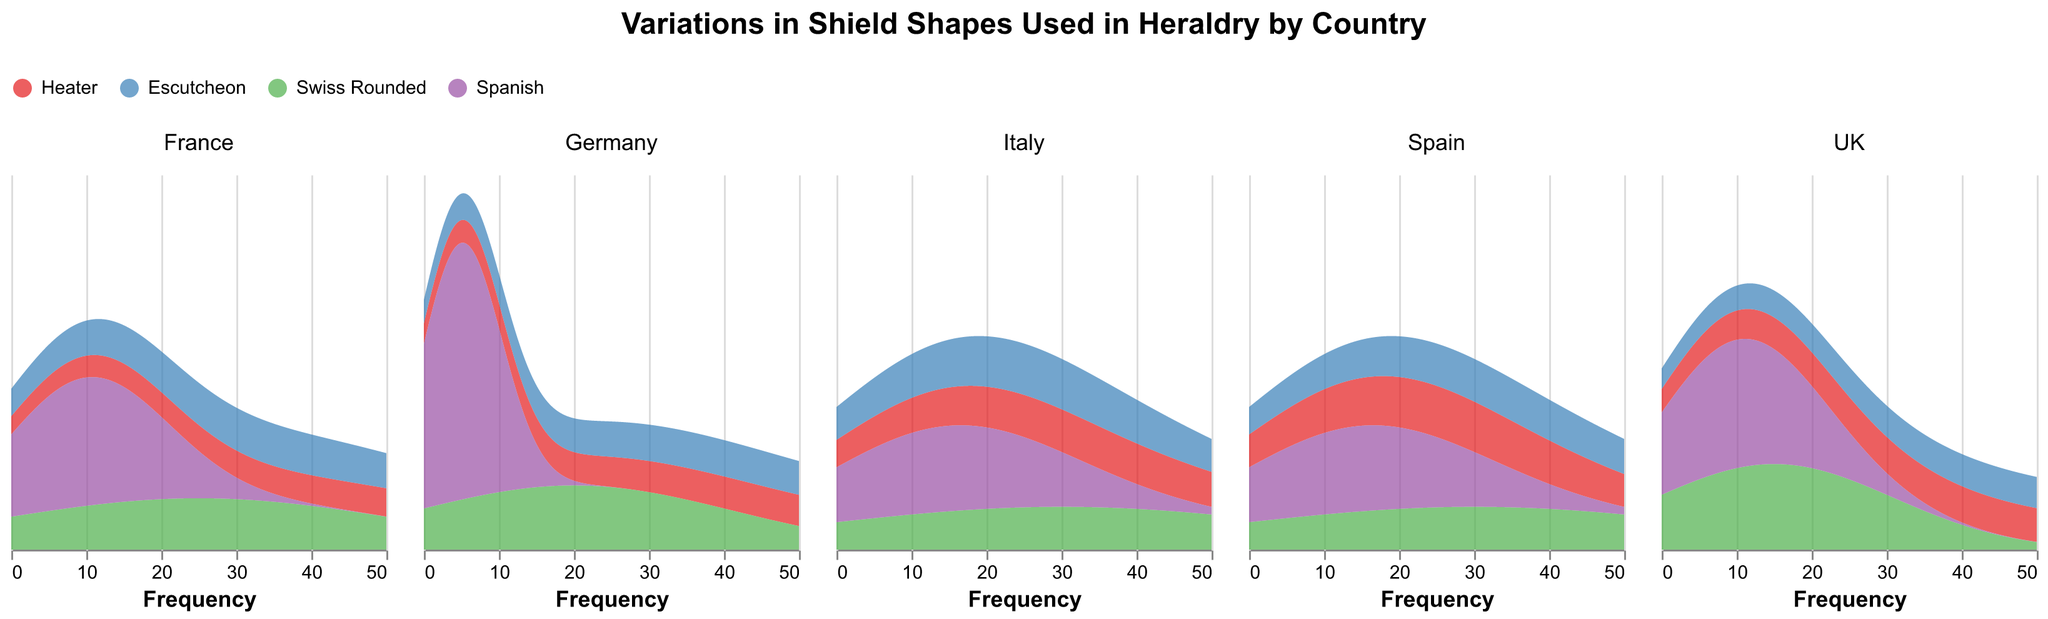What is the most common shield shape in France? To determine this, you can look at the highest peak in the density plot for France. Heater has the highest frequency with 45.
Answer: Heater Which country has the highest frequency for the Escutcheon shield shape? You need to compare the peaks for the Escutcheon shape in all countries. The UK shows the highest peak at a frequency of 40.
Answer: UK How many shield shapes are displayed in each subplot? Each subplot represents four different shield shapes as indicated by the color legend: Heater, Escutcheon, Swiss Rounded, and Spanish.
Answer: 4 Comparing Germany and Italy, which country uses the Swiss Rounded shape more frequently? Look at the heights of the density plots for Swiss Rounded in Germany and Italy. Italy has a higher frequency of 30 compared to Germany's 20.
Answer: Italy What is the combined frequency of the Spanish shield shape in Spain and Italy? Sum the frequencies of the Spanish shield shape in Spain (15) and Italy (15): 15 + 15 = 30.
Answer: 30 Which shield shape is the least common in Germany? By reviewing the density plot for Germany, the shape with the lowest frequency is Spanish with 5.
Answer: Spanish In which country is the frequency of the Heater shield shape equal to the frequency of the Escutcheon shield shape? Check for subplots where the density plots for Heater and Escutcheon have the same frequency. All frequencies of Heater and Escutcheon match in Spain (both 25).
Answer: Spain What is the most varied country in terms of the diversity of shield shapes? Evaluate the range and differences in the heights of density plots across shield shapes within each subplot. The UK appears most diverse with significant variations, especially high in Escutcheon and moderate in others.
Answer: UK What would be the total frequency for Heater shield shape across all countries? Sum the frequencies for the Heater shape in all countries: 45 (France) + 40 (Germany) + 30 (Italy) + 35 (UK) + 25 (Spain) = 175.
Answer: 175 Which shield shape has the lowest overall presence in the dataset? The Spanish shield appears to have consistently lower frequencies across all countries, summing to the lowest total overall. Analyzing Spain (15), UK (10), Germany (5), Italy (15), France (10) gives: 15+10+5+15+10 = 55.
Answer: Spanish 